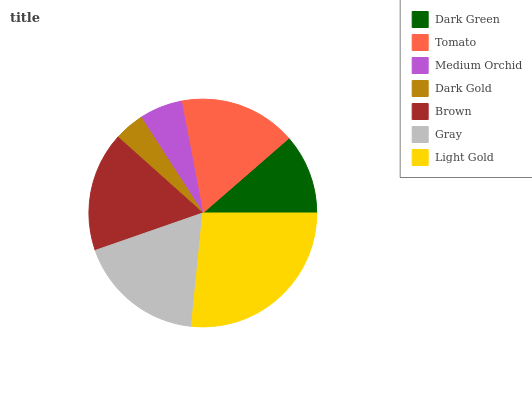Is Dark Gold the minimum?
Answer yes or no. Yes. Is Light Gold the maximum?
Answer yes or no. Yes. Is Tomato the minimum?
Answer yes or no. No. Is Tomato the maximum?
Answer yes or no. No. Is Tomato greater than Dark Green?
Answer yes or no. Yes. Is Dark Green less than Tomato?
Answer yes or no. Yes. Is Dark Green greater than Tomato?
Answer yes or no. No. Is Tomato less than Dark Green?
Answer yes or no. No. Is Tomato the high median?
Answer yes or no. Yes. Is Tomato the low median?
Answer yes or no. Yes. Is Brown the high median?
Answer yes or no. No. Is Dark Green the low median?
Answer yes or no. No. 